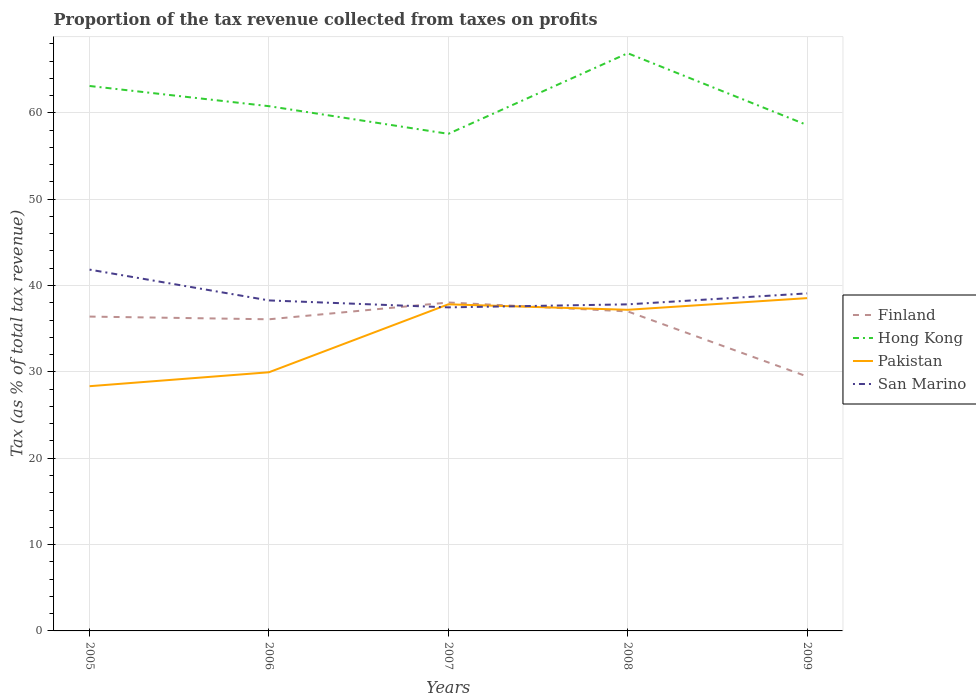How many different coloured lines are there?
Provide a succinct answer. 4. Does the line corresponding to San Marino intersect with the line corresponding to Hong Kong?
Offer a very short reply. No. Is the number of lines equal to the number of legend labels?
Your answer should be very brief. Yes. Across all years, what is the maximum proportion of the tax revenue collected in San Marino?
Give a very brief answer. 37.47. What is the total proportion of the tax revenue collected in Hong Kong in the graph?
Make the answer very short. 3.2. What is the difference between the highest and the second highest proportion of the tax revenue collected in Hong Kong?
Your answer should be compact. 9.33. What is the difference between the highest and the lowest proportion of the tax revenue collected in San Marino?
Give a very brief answer. 2. How many lines are there?
Your answer should be very brief. 4. How many years are there in the graph?
Keep it short and to the point. 5. Are the values on the major ticks of Y-axis written in scientific E-notation?
Your answer should be very brief. No. Does the graph contain any zero values?
Make the answer very short. No. Where does the legend appear in the graph?
Your answer should be very brief. Center right. What is the title of the graph?
Give a very brief answer. Proportion of the tax revenue collected from taxes on profits. Does "Tajikistan" appear as one of the legend labels in the graph?
Your answer should be compact. No. What is the label or title of the Y-axis?
Keep it short and to the point. Tax (as % of total tax revenue). What is the Tax (as % of total tax revenue) in Finland in 2005?
Your answer should be very brief. 36.4. What is the Tax (as % of total tax revenue) in Hong Kong in 2005?
Keep it short and to the point. 63.11. What is the Tax (as % of total tax revenue) in Pakistan in 2005?
Your response must be concise. 28.34. What is the Tax (as % of total tax revenue) in San Marino in 2005?
Your answer should be very brief. 41.84. What is the Tax (as % of total tax revenue) in Finland in 2006?
Ensure brevity in your answer.  36.09. What is the Tax (as % of total tax revenue) in Hong Kong in 2006?
Your answer should be very brief. 60.77. What is the Tax (as % of total tax revenue) in Pakistan in 2006?
Provide a short and direct response. 29.96. What is the Tax (as % of total tax revenue) of San Marino in 2006?
Provide a short and direct response. 38.28. What is the Tax (as % of total tax revenue) in Finland in 2007?
Your response must be concise. 38.03. What is the Tax (as % of total tax revenue) of Hong Kong in 2007?
Offer a terse response. 57.57. What is the Tax (as % of total tax revenue) of Pakistan in 2007?
Offer a terse response. 37.82. What is the Tax (as % of total tax revenue) in San Marino in 2007?
Offer a very short reply. 37.47. What is the Tax (as % of total tax revenue) of Finland in 2008?
Offer a terse response. 37. What is the Tax (as % of total tax revenue) of Hong Kong in 2008?
Make the answer very short. 66.9. What is the Tax (as % of total tax revenue) in Pakistan in 2008?
Provide a succinct answer. 37.19. What is the Tax (as % of total tax revenue) in San Marino in 2008?
Your answer should be very brief. 37.82. What is the Tax (as % of total tax revenue) in Finland in 2009?
Provide a succinct answer. 29.46. What is the Tax (as % of total tax revenue) in Hong Kong in 2009?
Give a very brief answer. 58.59. What is the Tax (as % of total tax revenue) of Pakistan in 2009?
Offer a terse response. 38.54. What is the Tax (as % of total tax revenue) of San Marino in 2009?
Keep it short and to the point. 39.09. Across all years, what is the maximum Tax (as % of total tax revenue) of Finland?
Ensure brevity in your answer.  38.03. Across all years, what is the maximum Tax (as % of total tax revenue) in Hong Kong?
Offer a terse response. 66.9. Across all years, what is the maximum Tax (as % of total tax revenue) in Pakistan?
Your answer should be very brief. 38.54. Across all years, what is the maximum Tax (as % of total tax revenue) in San Marino?
Offer a terse response. 41.84. Across all years, what is the minimum Tax (as % of total tax revenue) in Finland?
Give a very brief answer. 29.46. Across all years, what is the minimum Tax (as % of total tax revenue) of Hong Kong?
Ensure brevity in your answer.  57.57. Across all years, what is the minimum Tax (as % of total tax revenue) in Pakistan?
Keep it short and to the point. 28.34. Across all years, what is the minimum Tax (as % of total tax revenue) in San Marino?
Provide a succinct answer. 37.47. What is the total Tax (as % of total tax revenue) in Finland in the graph?
Your answer should be compact. 176.99. What is the total Tax (as % of total tax revenue) of Hong Kong in the graph?
Your answer should be compact. 306.94. What is the total Tax (as % of total tax revenue) of Pakistan in the graph?
Give a very brief answer. 171.85. What is the total Tax (as % of total tax revenue) in San Marino in the graph?
Your answer should be compact. 194.5. What is the difference between the Tax (as % of total tax revenue) of Finland in 2005 and that in 2006?
Provide a short and direct response. 0.31. What is the difference between the Tax (as % of total tax revenue) in Hong Kong in 2005 and that in 2006?
Keep it short and to the point. 2.34. What is the difference between the Tax (as % of total tax revenue) in Pakistan in 2005 and that in 2006?
Your answer should be very brief. -1.61. What is the difference between the Tax (as % of total tax revenue) of San Marino in 2005 and that in 2006?
Your answer should be very brief. 3.57. What is the difference between the Tax (as % of total tax revenue) in Finland in 2005 and that in 2007?
Your answer should be compact. -1.63. What is the difference between the Tax (as % of total tax revenue) in Hong Kong in 2005 and that in 2007?
Ensure brevity in your answer.  5.54. What is the difference between the Tax (as % of total tax revenue) of Pakistan in 2005 and that in 2007?
Give a very brief answer. -9.48. What is the difference between the Tax (as % of total tax revenue) of San Marino in 2005 and that in 2007?
Keep it short and to the point. 4.37. What is the difference between the Tax (as % of total tax revenue) of Finland in 2005 and that in 2008?
Make the answer very short. -0.6. What is the difference between the Tax (as % of total tax revenue) in Hong Kong in 2005 and that in 2008?
Ensure brevity in your answer.  -3.79. What is the difference between the Tax (as % of total tax revenue) in Pakistan in 2005 and that in 2008?
Your answer should be compact. -8.85. What is the difference between the Tax (as % of total tax revenue) in San Marino in 2005 and that in 2008?
Give a very brief answer. 4.02. What is the difference between the Tax (as % of total tax revenue) of Finland in 2005 and that in 2009?
Offer a terse response. 6.94. What is the difference between the Tax (as % of total tax revenue) of Hong Kong in 2005 and that in 2009?
Ensure brevity in your answer.  4.52. What is the difference between the Tax (as % of total tax revenue) in Pakistan in 2005 and that in 2009?
Make the answer very short. -10.2. What is the difference between the Tax (as % of total tax revenue) in San Marino in 2005 and that in 2009?
Your answer should be very brief. 2.75. What is the difference between the Tax (as % of total tax revenue) in Finland in 2006 and that in 2007?
Provide a succinct answer. -1.94. What is the difference between the Tax (as % of total tax revenue) in Hong Kong in 2006 and that in 2007?
Your answer should be very brief. 3.2. What is the difference between the Tax (as % of total tax revenue) in Pakistan in 2006 and that in 2007?
Your answer should be compact. -7.87. What is the difference between the Tax (as % of total tax revenue) in San Marino in 2006 and that in 2007?
Your response must be concise. 0.8. What is the difference between the Tax (as % of total tax revenue) in Finland in 2006 and that in 2008?
Ensure brevity in your answer.  -0.91. What is the difference between the Tax (as % of total tax revenue) of Hong Kong in 2006 and that in 2008?
Offer a very short reply. -6.13. What is the difference between the Tax (as % of total tax revenue) of Pakistan in 2006 and that in 2008?
Give a very brief answer. -7.23. What is the difference between the Tax (as % of total tax revenue) of San Marino in 2006 and that in 2008?
Provide a short and direct response. 0.46. What is the difference between the Tax (as % of total tax revenue) in Finland in 2006 and that in 2009?
Make the answer very short. 6.63. What is the difference between the Tax (as % of total tax revenue) of Hong Kong in 2006 and that in 2009?
Your answer should be very brief. 2.18. What is the difference between the Tax (as % of total tax revenue) of Pakistan in 2006 and that in 2009?
Provide a short and direct response. -8.59. What is the difference between the Tax (as % of total tax revenue) in San Marino in 2006 and that in 2009?
Your response must be concise. -0.81. What is the difference between the Tax (as % of total tax revenue) in Finland in 2007 and that in 2008?
Your answer should be very brief. 1.03. What is the difference between the Tax (as % of total tax revenue) of Hong Kong in 2007 and that in 2008?
Keep it short and to the point. -9.33. What is the difference between the Tax (as % of total tax revenue) in Pakistan in 2007 and that in 2008?
Your answer should be very brief. 0.63. What is the difference between the Tax (as % of total tax revenue) in San Marino in 2007 and that in 2008?
Provide a short and direct response. -0.35. What is the difference between the Tax (as % of total tax revenue) of Finland in 2007 and that in 2009?
Offer a terse response. 8.57. What is the difference between the Tax (as % of total tax revenue) of Hong Kong in 2007 and that in 2009?
Make the answer very short. -1.02. What is the difference between the Tax (as % of total tax revenue) of Pakistan in 2007 and that in 2009?
Keep it short and to the point. -0.72. What is the difference between the Tax (as % of total tax revenue) of San Marino in 2007 and that in 2009?
Provide a short and direct response. -1.62. What is the difference between the Tax (as % of total tax revenue) in Finland in 2008 and that in 2009?
Offer a terse response. 7.54. What is the difference between the Tax (as % of total tax revenue) in Hong Kong in 2008 and that in 2009?
Give a very brief answer. 8.32. What is the difference between the Tax (as % of total tax revenue) of Pakistan in 2008 and that in 2009?
Your answer should be very brief. -1.35. What is the difference between the Tax (as % of total tax revenue) of San Marino in 2008 and that in 2009?
Provide a succinct answer. -1.27. What is the difference between the Tax (as % of total tax revenue) in Finland in 2005 and the Tax (as % of total tax revenue) in Hong Kong in 2006?
Provide a succinct answer. -24.37. What is the difference between the Tax (as % of total tax revenue) of Finland in 2005 and the Tax (as % of total tax revenue) of Pakistan in 2006?
Your response must be concise. 6.45. What is the difference between the Tax (as % of total tax revenue) of Finland in 2005 and the Tax (as % of total tax revenue) of San Marino in 2006?
Provide a short and direct response. -1.87. What is the difference between the Tax (as % of total tax revenue) in Hong Kong in 2005 and the Tax (as % of total tax revenue) in Pakistan in 2006?
Ensure brevity in your answer.  33.15. What is the difference between the Tax (as % of total tax revenue) of Hong Kong in 2005 and the Tax (as % of total tax revenue) of San Marino in 2006?
Your answer should be compact. 24.83. What is the difference between the Tax (as % of total tax revenue) in Pakistan in 2005 and the Tax (as % of total tax revenue) in San Marino in 2006?
Make the answer very short. -9.93. What is the difference between the Tax (as % of total tax revenue) of Finland in 2005 and the Tax (as % of total tax revenue) of Hong Kong in 2007?
Offer a very short reply. -21.17. What is the difference between the Tax (as % of total tax revenue) in Finland in 2005 and the Tax (as % of total tax revenue) in Pakistan in 2007?
Give a very brief answer. -1.42. What is the difference between the Tax (as % of total tax revenue) in Finland in 2005 and the Tax (as % of total tax revenue) in San Marino in 2007?
Offer a terse response. -1.07. What is the difference between the Tax (as % of total tax revenue) of Hong Kong in 2005 and the Tax (as % of total tax revenue) of Pakistan in 2007?
Ensure brevity in your answer.  25.29. What is the difference between the Tax (as % of total tax revenue) of Hong Kong in 2005 and the Tax (as % of total tax revenue) of San Marino in 2007?
Provide a succinct answer. 25.64. What is the difference between the Tax (as % of total tax revenue) of Pakistan in 2005 and the Tax (as % of total tax revenue) of San Marino in 2007?
Your answer should be very brief. -9.13. What is the difference between the Tax (as % of total tax revenue) of Finland in 2005 and the Tax (as % of total tax revenue) of Hong Kong in 2008?
Offer a very short reply. -30.5. What is the difference between the Tax (as % of total tax revenue) of Finland in 2005 and the Tax (as % of total tax revenue) of Pakistan in 2008?
Keep it short and to the point. -0.79. What is the difference between the Tax (as % of total tax revenue) of Finland in 2005 and the Tax (as % of total tax revenue) of San Marino in 2008?
Make the answer very short. -1.42. What is the difference between the Tax (as % of total tax revenue) in Hong Kong in 2005 and the Tax (as % of total tax revenue) in Pakistan in 2008?
Provide a succinct answer. 25.92. What is the difference between the Tax (as % of total tax revenue) of Hong Kong in 2005 and the Tax (as % of total tax revenue) of San Marino in 2008?
Provide a short and direct response. 25.29. What is the difference between the Tax (as % of total tax revenue) in Pakistan in 2005 and the Tax (as % of total tax revenue) in San Marino in 2008?
Make the answer very short. -9.48. What is the difference between the Tax (as % of total tax revenue) of Finland in 2005 and the Tax (as % of total tax revenue) of Hong Kong in 2009?
Your response must be concise. -22.18. What is the difference between the Tax (as % of total tax revenue) in Finland in 2005 and the Tax (as % of total tax revenue) in Pakistan in 2009?
Offer a terse response. -2.14. What is the difference between the Tax (as % of total tax revenue) of Finland in 2005 and the Tax (as % of total tax revenue) of San Marino in 2009?
Your response must be concise. -2.69. What is the difference between the Tax (as % of total tax revenue) of Hong Kong in 2005 and the Tax (as % of total tax revenue) of Pakistan in 2009?
Your answer should be very brief. 24.57. What is the difference between the Tax (as % of total tax revenue) of Hong Kong in 2005 and the Tax (as % of total tax revenue) of San Marino in 2009?
Your answer should be compact. 24.02. What is the difference between the Tax (as % of total tax revenue) of Pakistan in 2005 and the Tax (as % of total tax revenue) of San Marino in 2009?
Your answer should be very brief. -10.75. What is the difference between the Tax (as % of total tax revenue) of Finland in 2006 and the Tax (as % of total tax revenue) of Hong Kong in 2007?
Keep it short and to the point. -21.48. What is the difference between the Tax (as % of total tax revenue) of Finland in 2006 and the Tax (as % of total tax revenue) of Pakistan in 2007?
Keep it short and to the point. -1.73. What is the difference between the Tax (as % of total tax revenue) in Finland in 2006 and the Tax (as % of total tax revenue) in San Marino in 2007?
Make the answer very short. -1.38. What is the difference between the Tax (as % of total tax revenue) of Hong Kong in 2006 and the Tax (as % of total tax revenue) of Pakistan in 2007?
Offer a very short reply. 22.95. What is the difference between the Tax (as % of total tax revenue) of Hong Kong in 2006 and the Tax (as % of total tax revenue) of San Marino in 2007?
Your response must be concise. 23.3. What is the difference between the Tax (as % of total tax revenue) in Pakistan in 2006 and the Tax (as % of total tax revenue) in San Marino in 2007?
Your answer should be compact. -7.52. What is the difference between the Tax (as % of total tax revenue) of Finland in 2006 and the Tax (as % of total tax revenue) of Hong Kong in 2008?
Provide a succinct answer. -30.81. What is the difference between the Tax (as % of total tax revenue) of Finland in 2006 and the Tax (as % of total tax revenue) of Pakistan in 2008?
Keep it short and to the point. -1.1. What is the difference between the Tax (as % of total tax revenue) of Finland in 2006 and the Tax (as % of total tax revenue) of San Marino in 2008?
Offer a terse response. -1.73. What is the difference between the Tax (as % of total tax revenue) in Hong Kong in 2006 and the Tax (as % of total tax revenue) in Pakistan in 2008?
Your answer should be very brief. 23.58. What is the difference between the Tax (as % of total tax revenue) in Hong Kong in 2006 and the Tax (as % of total tax revenue) in San Marino in 2008?
Offer a very short reply. 22.95. What is the difference between the Tax (as % of total tax revenue) in Pakistan in 2006 and the Tax (as % of total tax revenue) in San Marino in 2008?
Keep it short and to the point. -7.87. What is the difference between the Tax (as % of total tax revenue) in Finland in 2006 and the Tax (as % of total tax revenue) in Hong Kong in 2009?
Make the answer very short. -22.5. What is the difference between the Tax (as % of total tax revenue) in Finland in 2006 and the Tax (as % of total tax revenue) in Pakistan in 2009?
Ensure brevity in your answer.  -2.45. What is the difference between the Tax (as % of total tax revenue) in Finland in 2006 and the Tax (as % of total tax revenue) in San Marino in 2009?
Offer a very short reply. -3. What is the difference between the Tax (as % of total tax revenue) in Hong Kong in 2006 and the Tax (as % of total tax revenue) in Pakistan in 2009?
Offer a very short reply. 22.23. What is the difference between the Tax (as % of total tax revenue) of Hong Kong in 2006 and the Tax (as % of total tax revenue) of San Marino in 2009?
Provide a short and direct response. 21.68. What is the difference between the Tax (as % of total tax revenue) in Pakistan in 2006 and the Tax (as % of total tax revenue) in San Marino in 2009?
Give a very brief answer. -9.13. What is the difference between the Tax (as % of total tax revenue) of Finland in 2007 and the Tax (as % of total tax revenue) of Hong Kong in 2008?
Your answer should be very brief. -28.87. What is the difference between the Tax (as % of total tax revenue) in Finland in 2007 and the Tax (as % of total tax revenue) in Pakistan in 2008?
Ensure brevity in your answer.  0.84. What is the difference between the Tax (as % of total tax revenue) in Finland in 2007 and the Tax (as % of total tax revenue) in San Marino in 2008?
Provide a short and direct response. 0.21. What is the difference between the Tax (as % of total tax revenue) in Hong Kong in 2007 and the Tax (as % of total tax revenue) in Pakistan in 2008?
Make the answer very short. 20.38. What is the difference between the Tax (as % of total tax revenue) of Hong Kong in 2007 and the Tax (as % of total tax revenue) of San Marino in 2008?
Offer a terse response. 19.75. What is the difference between the Tax (as % of total tax revenue) of Pakistan in 2007 and the Tax (as % of total tax revenue) of San Marino in 2008?
Keep it short and to the point. 0. What is the difference between the Tax (as % of total tax revenue) of Finland in 2007 and the Tax (as % of total tax revenue) of Hong Kong in 2009?
Your answer should be very brief. -20.55. What is the difference between the Tax (as % of total tax revenue) in Finland in 2007 and the Tax (as % of total tax revenue) in Pakistan in 2009?
Make the answer very short. -0.51. What is the difference between the Tax (as % of total tax revenue) in Finland in 2007 and the Tax (as % of total tax revenue) in San Marino in 2009?
Give a very brief answer. -1.05. What is the difference between the Tax (as % of total tax revenue) of Hong Kong in 2007 and the Tax (as % of total tax revenue) of Pakistan in 2009?
Your answer should be very brief. 19.03. What is the difference between the Tax (as % of total tax revenue) of Hong Kong in 2007 and the Tax (as % of total tax revenue) of San Marino in 2009?
Offer a terse response. 18.48. What is the difference between the Tax (as % of total tax revenue) of Pakistan in 2007 and the Tax (as % of total tax revenue) of San Marino in 2009?
Provide a succinct answer. -1.27. What is the difference between the Tax (as % of total tax revenue) in Finland in 2008 and the Tax (as % of total tax revenue) in Hong Kong in 2009?
Your response must be concise. -21.58. What is the difference between the Tax (as % of total tax revenue) in Finland in 2008 and the Tax (as % of total tax revenue) in Pakistan in 2009?
Provide a short and direct response. -1.54. What is the difference between the Tax (as % of total tax revenue) in Finland in 2008 and the Tax (as % of total tax revenue) in San Marino in 2009?
Your answer should be compact. -2.09. What is the difference between the Tax (as % of total tax revenue) of Hong Kong in 2008 and the Tax (as % of total tax revenue) of Pakistan in 2009?
Provide a succinct answer. 28.36. What is the difference between the Tax (as % of total tax revenue) of Hong Kong in 2008 and the Tax (as % of total tax revenue) of San Marino in 2009?
Give a very brief answer. 27.81. What is the difference between the Tax (as % of total tax revenue) in Pakistan in 2008 and the Tax (as % of total tax revenue) in San Marino in 2009?
Provide a short and direct response. -1.9. What is the average Tax (as % of total tax revenue) in Finland per year?
Your answer should be very brief. 35.4. What is the average Tax (as % of total tax revenue) in Hong Kong per year?
Offer a terse response. 61.39. What is the average Tax (as % of total tax revenue) of Pakistan per year?
Make the answer very short. 34.37. What is the average Tax (as % of total tax revenue) of San Marino per year?
Give a very brief answer. 38.9. In the year 2005, what is the difference between the Tax (as % of total tax revenue) in Finland and Tax (as % of total tax revenue) in Hong Kong?
Provide a succinct answer. -26.71. In the year 2005, what is the difference between the Tax (as % of total tax revenue) of Finland and Tax (as % of total tax revenue) of Pakistan?
Your answer should be very brief. 8.06. In the year 2005, what is the difference between the Tax (as % of total tax revenue) of Finland and Tax (as % of total tax revenue) of San Marino?
Your answer should be compact. -5.44. In the year 2005, what is the difference between the Tax (as % of total tax revenue) of Hong Kong and Tax (as % of total tax revenue) of Pakistan?
Give a very brief answer. 34.77. In the year 2005, what is the difference between the Tax (as % of total tax revenue) in Hong Kong and Tax (as % of total tax revenue) in San Marino?
Give a very brief answer. 21.27. In the year 2005, what is the difference between the Tax (as % of total tax revenue) in Pakistan and Tax (as % of total tax revenue) in San Marino?
Your response must be concise. -13.5. In the year 2006, what is the difference between the Tax (as % of total tax revenue) of Finland and Tax (as % of total tax revenue) of Hong Kong?
Provide a short and direct response. -24.68. In the year 2006, what is the difference between the Tax (as % of total tax revenue) of Finland and Tax (as % of total tax revenue) of Pakistan?
Make the answer very short. 6.13. In the year 2006, what is the difference between the Tax (as % of total tax revenue) of Finland and Tax (as % of total tax revenue) of San Marino?
Your answer should be compact. -2.19. In the year 2006, what is the difference between the Tax (as % of total tax revenue) of Hong Kong and Tax (as % of total tax revenue) of Pakistan?
Your answer should be very brief. 30.81. In the year 2006, what is the difference between the Tax (as % of total tax revenue) in Hong Kong and Tax (as % of total tax revenue) in San Marino?
Provide a succinct answer. 22.49. In the year 2006, what is the difference between the Tax (as % of total tax revenue) of Pakistan and Tax (as % of total tax revenue) of San Marino?
Provide a succinct answer. -8.32. In the year 2007, what is the difference between the Tax (as % of total tax revenue) in Finland and Tax (as % of total tax revenue) in Hong Kong?
Your response must be concise. -19.53. In the year 2007, what is the difference between the Tax (as % of total tax revenue) in Finland and Tax (as % of total tax revenue) in Pakistan?
Offer a terse response. 0.21. In the year 2007, what is the difference between the Tax (as % of total tax revenue) of Finland and Tax (as % of total tax revenue) of San Marino?
Offer a terse response. 0.56. In the year 2007, what is the difference between the Tax (as % of total tax revenue) of Hong Kong and Tax (as % of total tax revenue) of Pakistan?
Make the answer very short. 19.75. In the year 2007, what is the difference between the Tax (as % of total tax revenue) in Hong Kong and Tax (as % of total tax revenue) in San Marino?
Provide a short and direct response. 20.1. In the year 2007, what is the difference between the Tax (as % of total tax revenue) of Pakistan and Tax (as % of total tax revenue) of San Marino?
Keep it short and to the point. 0.35. In the year 2008, what is the difference between the Tax (as % of total tax revenue) in Finland and Tax (as % of total tax revenue) in Hong Kong?
Offer a terse response. -29.9. In the year 2008, what is the difference between the Tax (as % of total tax revenue) of Finland and Tax (as % of total tax revenue) of Pakistan?
Keep it short and to the point. -0.19. In the year 2008, what is the difference between the Tax (as % of total tax revenue) of Finland and Tax (as % of total tax revenue) of San Marino?
Offer a very short reply. -0.82. In the year 2008, what is the difference between the Tax (as % of total tax revenue) in Hong Kong and Tax (as % of total tax revenue) in Pakistan?
Your answer should be very brief. 29.71. In the year 2008, what is the difference between the Tax (as % of total tax revenue) of Hong Kong and Tax (as % of total tax revenue) of San Marino?
Make the answer very short. 29.08. In the year 2008, what is the difference between the Tax (as % of total tax revenue) in Pakistan and Tax (as % of total tax revenue) in San Marino?
Provide a short and direct response. -0.63. In the year 2009, what is the difference between the Tax (as % of total tax revenue) in Finland and Tax (as % of total tax revenue) in Hong Kong?
Your answer should be compact. -29.12. In the year 2009, what is the difference between the Tax (as % of total tax revenue) in Finland and Tax (as % of total tax revenue) in Pakistan?
Ensure brevity in your answer.  -9.08. In the year 2009, what is the difference between the Tax (as % of total tax revenue) of Finland and Tax (as % of total tax revenue) of San Marino?
Keep it short and to the point. -9.63. In the year 2009, what is the difference between the Tax (as % of total tax revenue) in Hong Kong and Tax (as % of total tax revenue) in Pakistan?
Offer a very short reply. 20.04. In the year 2009, what is the difference between the Tax (as % of total tax revenue) of Hong Kong and Tax (as % of total tax revenue) of San Marino?
Make the answer very short. 19.5. In the year 2009, what is the difference between the Tax (as % of total tax revenue) in Pakistan and Tax (as % of total tax revenue) in San Marino?
Provide a succinct answer. -0.55. What is the ratio of the Tax (as % of total tax revenue) in Finland in 2005 to that in 2006?
Provide a short and direct response. 1.01. What is the ratio of the Tax (as % of total tax revenue) in Pakistan in 2005 to that in 2006?
Offer a terse response. 0.95. What is the ratio of the Tax (as % of total tax revenue) in San Marino in 2005 to that in 2006?
Offer a very short reply. 1.09. What is the ratio of the Tax (as % of total tax revenue) of Finland in 2005 to that in 2007?
Provide a short and direct response. 0.96. What is the ratio of the Tax (as % of total tax revenue) in Hong Kong in 2005 to that in 2007?
Ensure brevity in your answer.  1.1. What is the ratio of the Tax (as % of total tax revenue) of Pakistan in 2005 to that in 2007?
Your response must be concise. 0.75. What is the ratio of the Tax (as % of total tax revenue) in San Marino in 2005 to that in 2007?
Provide a succinct answer. 1.12. What is the ratio of the Tax (as % of total tax revenue) in Finland in 2005 to that in 2008?
Offer a terse response. 0.98. What is the ratio of the Tax (as % of total tax revenue) in Hong Kong in 2005 to that in 2008?
Make the answer very short. 0.94. What is the ratio of the Tax (as % of total tax revenue) of Pakistan in 2005 to that in 2008?
Keep it short and to the point. 0.76. What is the ratio of the Tax (as % of total tax revenue) of San Marino in 2005 to that in 2008?
Give a very brief answer. 1.11. What is the ratio of the Tax (as % of total tax revenue) of Finland in 2005 to that in 2009?
Make the answer very short. 1.24. What is the ratio of the Tax (as % of total tax revenue) of Hong Kong in 2005 to that in 2009?
Offer a terse response. 1.08. What is the ratio of the Tax (as % of total tax revenue) of Pakistan in 2005 to that in 2009?
Give a very brief answer. 0.74. What is the ratio of the Tax (as % of total tax revenue) in San Marino in 2005 to that in 2009?
Provide a succinct answer. 1.07. What is the ratio of the Tax (as % of total tax revenue) of Finland in 2006 to that in 2007?
Provide a short and direct response. 0.95. What is the ratio of the Tax (as % of total tax revenue) of Hong Kong in 2006 to that in 2007?
Offer a terse response. 1.06. What is the ratio of the Tax (as % of total tax revenue) in Pakistan in 2006 to that in 2007?
Provide a succinct answer. 0.79. What is the ratio of the Tax (as % of total tax revenue) of San Marino in 2006 to that in 2007?
Provide a short and direct response. 1.02. What is the ratio of the Tax (as % of total tax revenue) of Finland in 2006 to that in 2008?
Offer a very short reply. 0.98. What is the ratio of the Tax (as % of total tax revenue) in Hong Kong in 2006 to that in 2008?
Ensure brevity in your answer.  0.91. What is the ratio of the Tax (as % of total tax revenue) of Pakistan in 2006 to that in 2008?
Keep it short and to the point. 0.81. What is the ratio of the Tax (as % of total tax revenue) in San Marino in 2006 to that in 2008?
Your answer should be compact. 1.01. What is the ratio of the Tax (as % of total tax revenue) of Finland in 2006 to that in 2009?
Your response must be concise. 1.22. What is the ratio of the Tax (as % of total tax revenue) in Hong Kong in 2006 to that in 2009?
Offer a very short reply. 1.04. What is the ratio of the Tax (as % of total tax revenue) in Pakistan in 2006 to that in 2009?
Keep it short and to the point. 0.78. What is the ratio of the Tax (as % of total tax revenue) in San Marino in 2006 to that in 2009?
Your answer should be compact. 0.98. What is the ratio of the Tax (as % of total tax revenue) of Finland in 2007 to that in 2008?
Make the answer very short. 1.03. What is the ratio of the Tax (as % of total tax revenue) in Hong Kong in 2007 to that in 2008?
Provide a short and direct response. 0.86. What is the ratio of the Tax (as % of total tax revenue) in Pakistan in 2007 to that in 2008?
Provide a short and direct response. 1.02. What is the ratio of the Tax (as % of total tax revenue) of Finland in 2007 to that in 2009?
Your answer should be compact. 1.29. What is the ratio of the Tax (as % of total tax revenue) in Hong Kong in 2007 to that in 2009?
Make the answer very short. 0.98. What is the ratio of the Tax (as % of total tax revenue) of Pakistan in 2007 to that in 2009?
Make the answer very short. 0.98. What is the ratio of the Tax (as % of total tax revenue) of San Marino in 2007 to that in 2009?
Give a very brief answer. 0.96. What is the ratio of the Tax (as % of total tax revenue) in Finland in 2008 to that in 2009?
Your response must be concise. 1.26. What is the ratio of the Tax (as % of total tax revenue) of Hong Kong in 2008 to that in 2009?
Your answer should be very brief. 1.14. What is the ratio of the Tax (as % of total tax revenue) in Pakistan in 2008 to that in 2009?
Provide a succinct answer. 0.96. What is the ratio of the Tax (as % of total tax revenue) of San Marino in 2008 to that in 2009?
Give a very brief answer. 0.97. What is the difference between the highest and the second highest Tax (as % of total tax revenue) of Finland?
Ensure brevity in your answer.  1.03. What is the difference between the highest and the second highest Tax (as % of total tax revenue) in Hong Kong?
Your response must be concise. 3.79. What is the difference between the highest and the second highest Tax (as % of total tax revenue) in Pakistan?
Your answer should be compact. 0.72. What is the difference between the highest and the second highest Tax (as % of total tax revenue) of San Marino?
Give a very brief answer. 2.75. What is the difference between the highest and the lowest Tax (as % of total tax revenue) in Finland?
Offer a terse response. 8.57. What is the difference between the highest and the lowest Tax (as % of total tax revenue) in Hong Kong?
Your answer should be compact. 9.33. What is the difference between the highest and the lowest Tax (as % of total tax revenue) in Pakistan?
Ensure brevity in your answer.  10.2. What is the difference between the highest and the lowest Tax (as % of total tax revenue) of San Marino?
Make the answer very short. 4.37. 